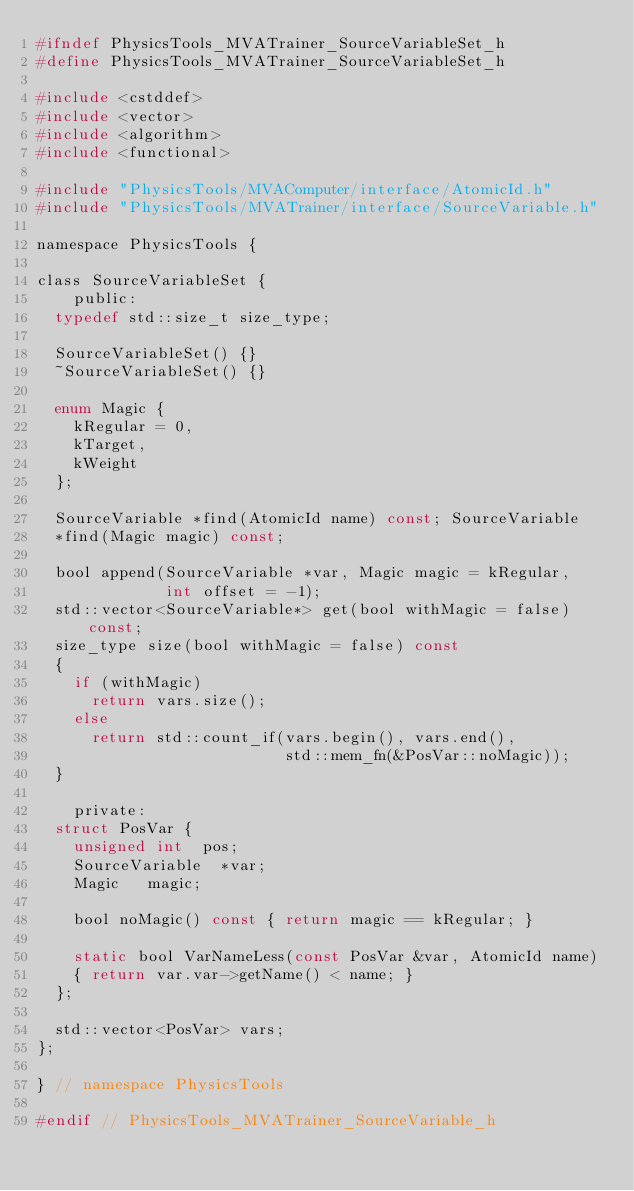<code> <loc_0><loc_0><loc_500><loc_500><_C_>#ifndef PhysicsTools_MVATrainer_SourceVariableSet_h
#define PhysicsTools_MVATrainer_SourceVariableSet_h

#include <cstddef>
#include <vector>
#include <algorithm>
#include <functional>

#include "PhysicsTools/MVAComputer/interface/AtomicId.h"
#include "PhysicsTools/MVATrainer/interface/SourceVariable.h"

namespace PhysicsTools {

class SourceVariableSet {
    public:
	typedef std::size_t size_type;

	SourceVariableSet() {}
	~SourceVariableSet() {}

	enum Magic {
		kRegular = 0,
		kTarget,
		kWeight
	};

	SourceVariable *find(AtomicId name) const; SourceVariable
	*find(Magic magic) const;

	bool append(SourceVariable *var, Magic magic = kRegular,
	            int offset = -1);
	std::vector<SourceVariable*> get(bool withMagic = false) const;
	size_type size(bool withMagic = false) const
	{
		if (withMagic)
			return vars.size();
		else
			return std::count_if(vars.begin(), vars.end(),
			                     std::mem_fn(&PosVar::noMagic));
	}

    private:
	struct PosVar {
		unsigned int	pos;
		SourceVariable	*var;
		Magic		magic;

		bool noMagic() const { return magic == kRegular; }

		static bool VarNameLess(const PosVar &var, AtomicId name)
		{ return var.var->getName() < name; }
	};

	std::vector<PosVar>	vars;
};

} // namespace PhysicsTools

#endif // PhysicsTools_MVATrainer_SourceVariable_h
</code> 